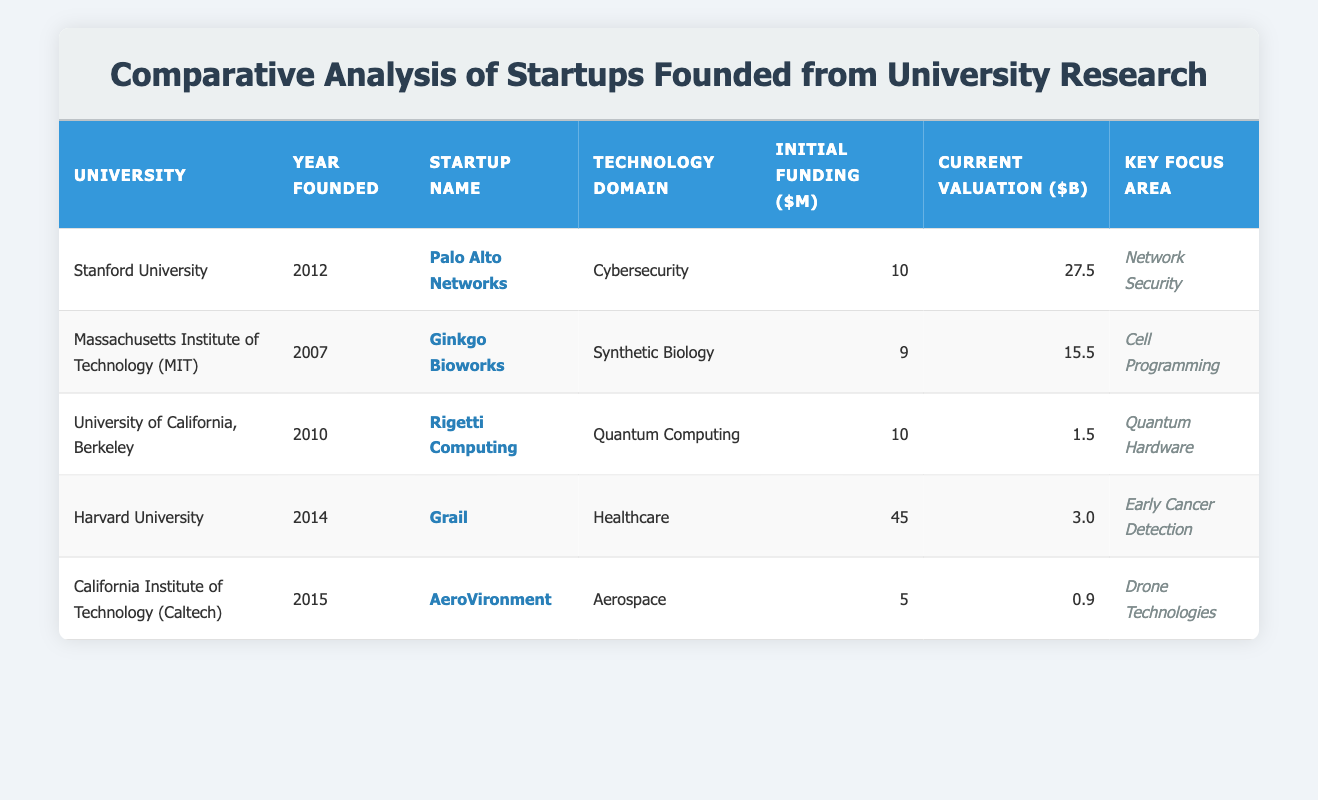What university founded the startup "Ginkgo Bioworks"? The table lists "Ginkgo Bioworks" under the Massachusetts Institute of Technology (MIT) row, indicating that it was founded there.
Answer: Massachusetts Institute of Technology (MIT) Which startup has the highest current valuation? The current valuations in the table are: Palo Alto Networks (27.5 billion), Ginkgo Bioworks (15.5 billion), Rigetti Computing (1.5 billion), Grail (3.0 billion), and AeroVironment (0.9 billion). The highest among these is Palo Alto Networks at 27.5 billion.
Answer: Palo Alto Networks What is the initial funding amount of the startup "Grail"? Referring to the row for Grail, the initial funding amount is listed as 45 million dollars.
Answer: 45 million dollars Is "AeroVironment" valued at over 1 billion dollars? The table shows that AeroVironment has a current valuation of 0.9 billion dollars, which is less than 1 billion.
Answer: No What is the average initial funding of the startups from the data provided? The initial funding amounts are: 10, 9, 10, 45, and 5 million dollars. Adding these amounts gives a total of 79 million. Since there are 5 startups, the average is 79 million divided by 5, which equals 15.8 million.
Answer: 15.8 million Which technology domain has the lowest current valuation? The current valuations are: Cybersecurity (27.5 billion), Synthetic Biology (15.5 billion), Quantum Computing (1.5 billion), Healthcare (3.0 billion), and Aerospace (0.9 billion). AeroVironment in the Aerospace domain has the lowest valuation at 0.9 billion.
Answer: Aerospace What is the key focus area of "Palo Alto Networks"? In the table, the key focus area for Palo Alto Networks is listed as "Network Security."
Answer: Network Security What is the difference in initial funding between "Grail" and "Rigetti Computing"? Initial funding for Grail is 45 million and for Rigetti Computing is 10 million. The difference is 45 million minus 10 million, which equals 35 million.
Answer: 35 million 